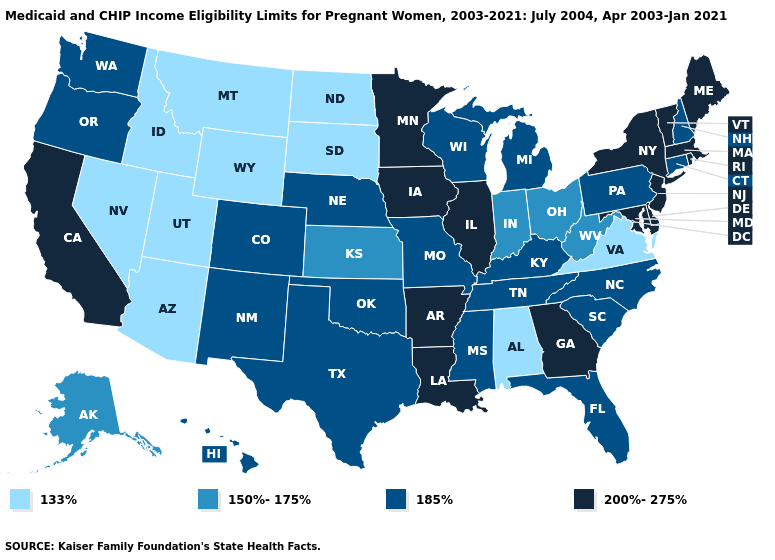What is the highest value in the West ?
Be succinct. 200%-275%. What is the value of Ohio?
Be succinct. 150%-175%. Does Montana have the lowest value in the West?
Write a very short answer. Yes. Does Wyoming have the highest value in the West?
Be succinct. No. What is the value of California?
Quick response, please. 200%-275%. Does Alabama have the lowest value in the South?
Write a very short answer. Yes. What is the lowest value in the South?
Concise answer only. 133%. Does Maine have the highest value in the USA?
Give a very brief answer. Yes. Does Louisiana have the same value as New Jersey?
Concise answer only. Yes. Name the states that have a value in the range 200%-275%?
Concise answer only. Arkansas, California, Delaware, Georgia, Illinois, Iowa, Louisiana, Maine, Maryland, Massachusetts, Minnesota, New Jersey, New York, Rhode Island, Vermont. Name the states that have a value in the range 150%-175%?
Be succinct. Alaska, Indiana, Kansas, Ohio, West Virginia. What is the value of Washington?
Write a very short answer. 185%. What is the highest value in the South ?
Short answer required. 200%-275%. What is the value of Maine?
Keep it brief. 200%-275%. What is the value of Washington?
Concise answer only. 185%. 